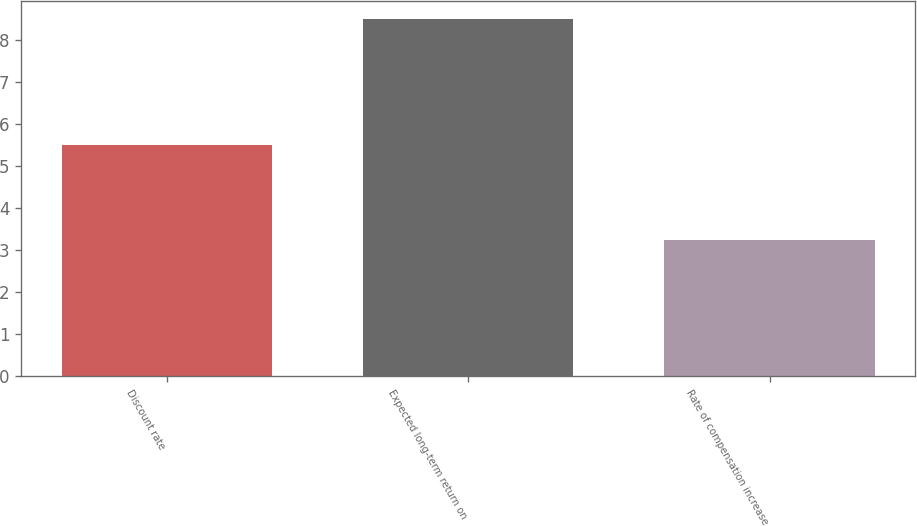Convert chart. <chart><loc_0><loc_0><loc_500><loc_500><bar_chart><fcel>Discount rate<fcel>Expected long-term return on<fcel>Rate of compensation increase<nl><fcel>5.5<fcel>8.5<fcel>3.25<nl></chart> 